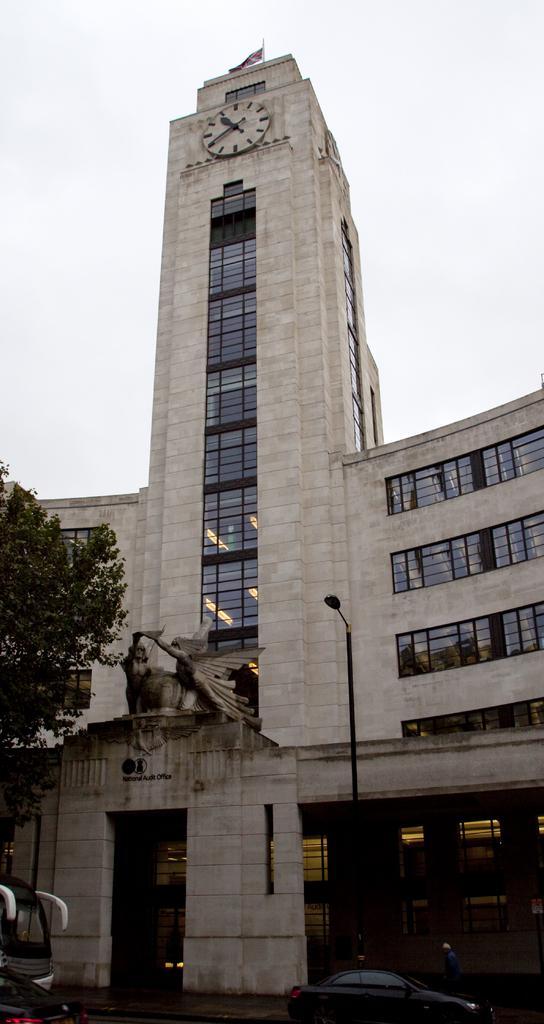Can you describe this image briefly? In this picture, there is a building with a clock on the top. At the entrance, there is a statue. Towards the left, there is a tree. At the bottom, there are vehicles. On the top, there is a sky. 